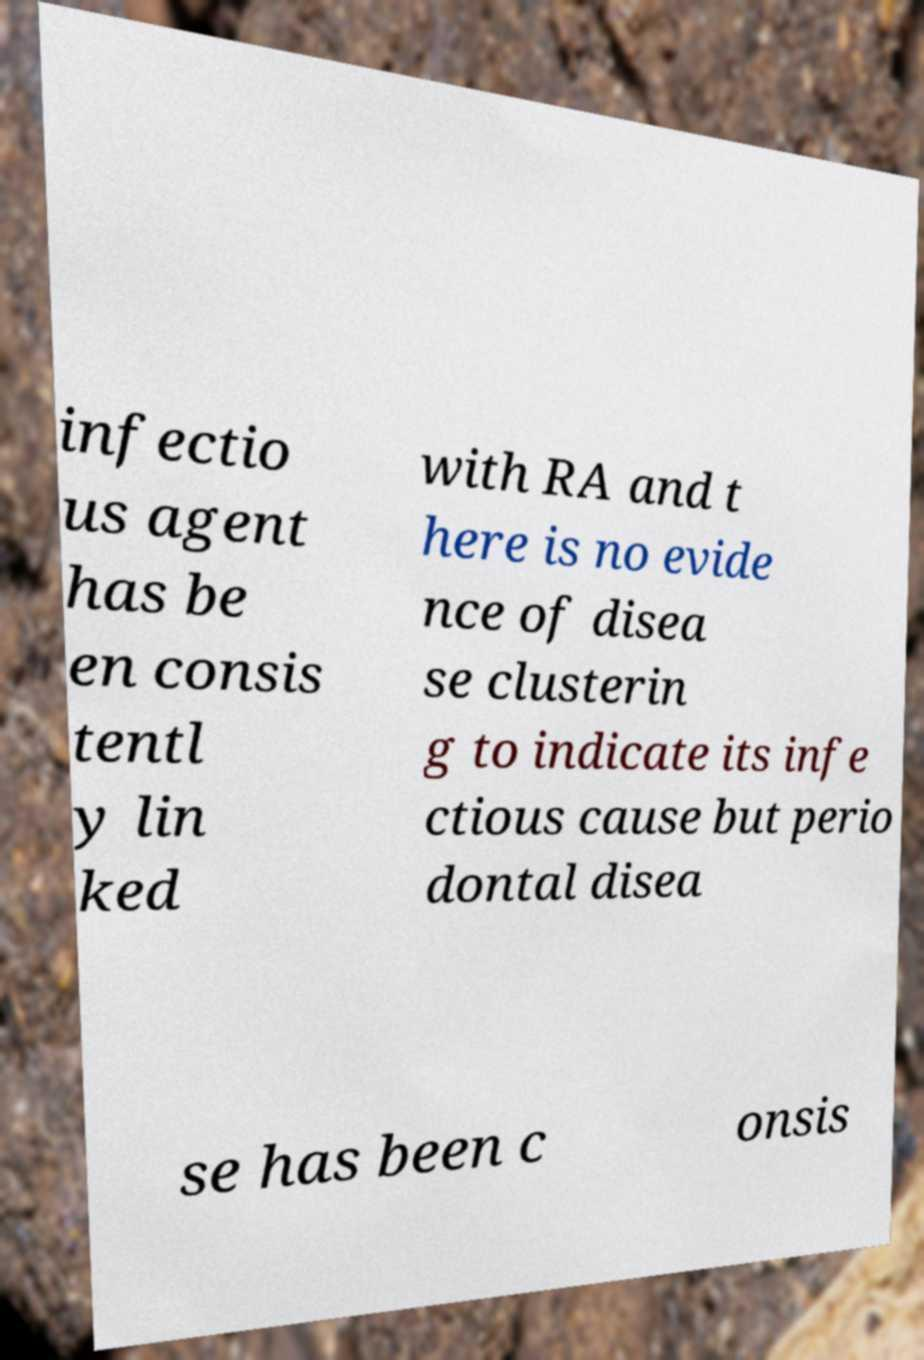Could you assist in decoding the text presented in this image and type it out clearly? infectio us agent has be en consis tentl y lin ked with RA and t here is no evide nce of disea se clusterin g to indicate its infe ctious cause but perio dontal disea se has been c onsis 